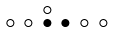Convert formula to latex. <formula><loc_0><loc_0><loc_500><loc_500>\begin{smallmatrix} & & \circ \\ \circ & \circ & \bullet & \bullet & \circ & \circ & \\ \end{smallmatrix}</formula> 